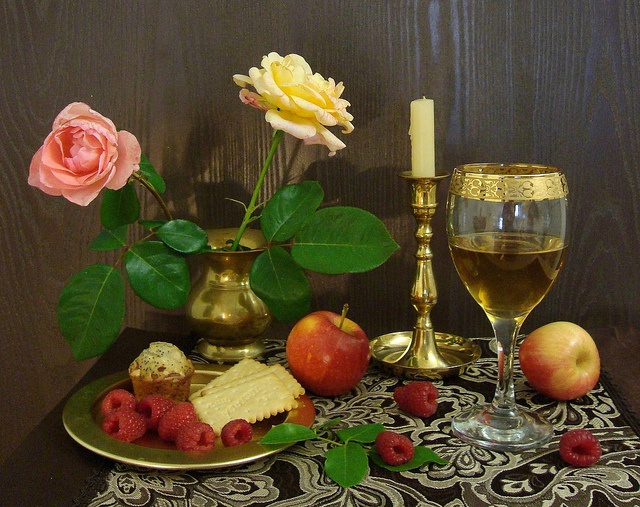Describe the objects in this image and their specific colors. I can see dining table in black, olive, gray, and maroon tones, wine glass in black, olive, gray, and maroon tones, vase in black and olive tones, apple in black, brown, and maroon tones, and apple in black, tan, brown, and maroon tones in this image. 